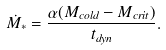<formula> <loc_0><loc_0><loc_500><loc_500>\dot { M _ { * } } = \frac { \alpha ( M _ { c o l d } - M _ { c r i t } ) } { t _ { d y n } } .</formula> 